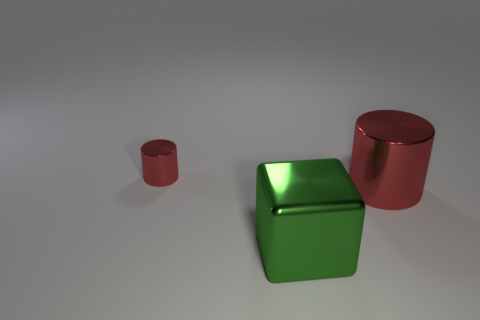Are there any other things that have the same color as the large metallic cube?
Your response must be concise. No. What is the material of the big green object that is left of the red metallic cylinder to the right of the tiny red object?
Offer a very short reply. Metal. How many objects are either red shiny cylinders left of the shiny cube or small yellow matte things?
Provide a succinct answer. 1. Are there any small cylinders of the same color as the tiny thing?
Keep it short and to the point. No. Do the large red metal object and the big green thing in front of the tiny metallic cylinder have the same shape?
Your answer should be compact. No. How many shiny things are behind the large cylinder and in front of the big red metallic cylinder?
Your answer should be very brief. 0. There is a big red thing that is the same shape as the small thing; what is its material?
Offer a very short reply. Metal. There is a object in front of the metal cylinder that is on the right side of the small red metallic object; what size is it?
Offer a terse response. Large. Are any big cylinders visible?
Your answer should be compact. Yes. The object that is both right of the tiny red metal thing and behind the green metallic object is made of what material?
Give a very brief answer. Metal. 